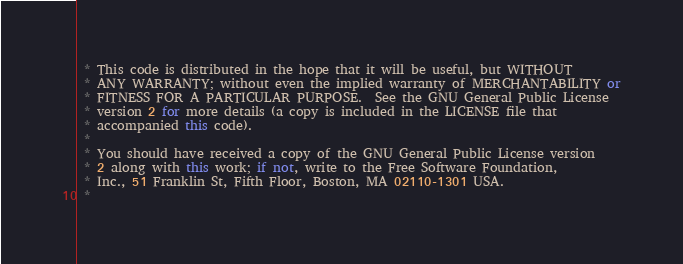<code> <loc_0><loc_0><loc_500><loc_500><_C++_> * This code is distributed in the hope that it will be useful, but WITHOUT
 * ANY WARRANTY; without even the implied warranty of MERCHANTABILITY or
 * FITNESS FOR A PARTICULAR PURPOSE.  See the GNU General Public License
 * version 2 for more details (a copy is included in the LICENSE file that
 * accompanied this code).
 *
 * You should have received a copy of the GNU General Public License version
 * 2 along with this work; if not, write to the Free Software Foundation,
 * Inc., 51 Franklin St, Fifth Floor, Boston, MA 02110-1301 USA.
 *</code> 